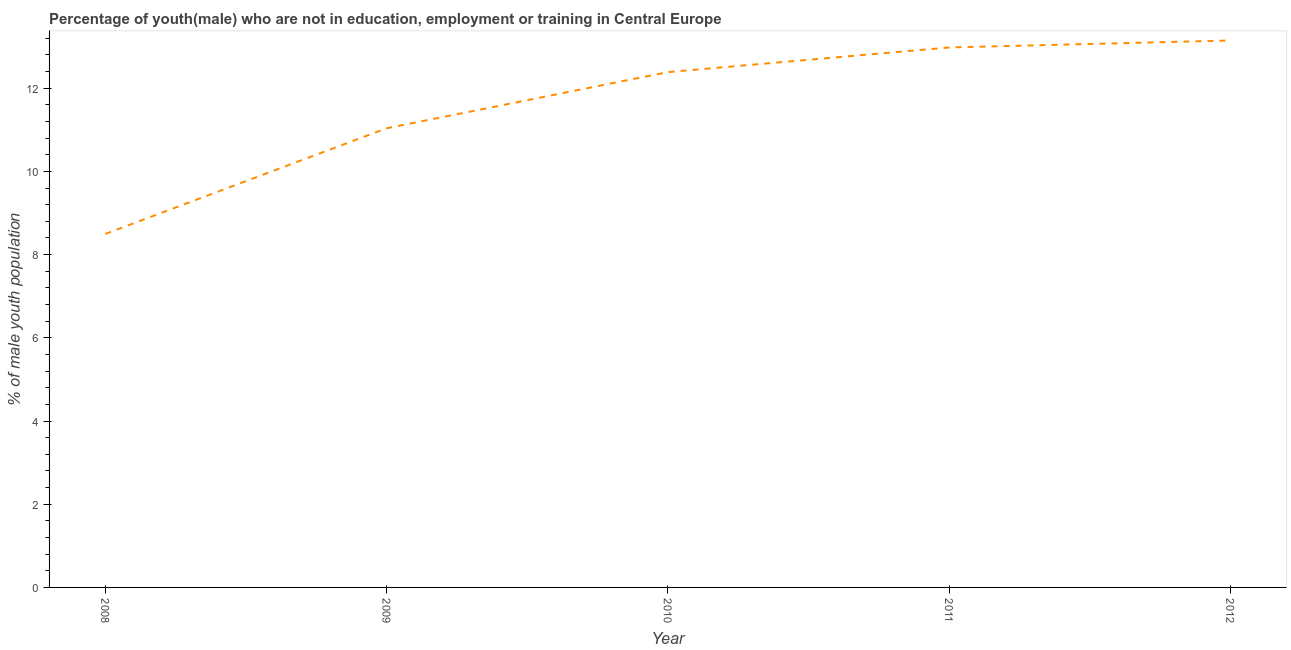What is the unemployed male youth population in 2008?
Your response must be concise. 8.5. Across all years, what is the maximum unemployed male youth population?
Give a very brief answer. 13.15. Across all years, what is the minimum unemployed male youth population?
Offer a very short reply. 8.5. In which year was the unemployed male youth population minimum?
Your answer should be very brief. 2008. What is the sum of the unemployed male youth population?
Provide a short and direct response. 58.05. What is the difference between the unemployed male youth population in 2010 and 2012?
Your answer should be very brief. -0.76. What is the average unemployed male youth population per year?
Your answer should be very brief. 11.61. What is the median unemployed male youth population?
Ensure brevity in your answer.  12.39. Do a majority of the years between 2010 and 2011 (inclusive) have unemployed male youth population greater than 4.4 %?
Give a very brief answer. Yes. What is the ratio of the unemployed male youth population in 2009 to that in 2012?
Make the answer very short. 0.84. Is the unemployed male youth population in 2010 less than that in 2011?
Offer a terse response. Yes. What is the difference between the highest and the second highest unemployed male youth population?
Make the answer very short. 0.17. What is the difference between the highest and the lowest unemployed male youth population?
Make the answer very short. 4.65. In how many years, is the unemployed male youth population greater than the average unemployed male youth population taken over all years?
Give a very brief answer. 3. What is the difference between two consecutive major ticks on the Y-axis?
Provide a short and direct response. 2. Does the graph contain any zero values?
Keep it short and to the point. No. What is the title of the graph?
Provide a succinct answer. Percentage of youth(male) who are not in education, employment or training in Central Europe. What is the label or title of the X-axis?
Give a very brief answer. Year. What is the label or title of the Y-axis?
Your answer should be compact. % of male youth population. What is the % of male youth population in 2008?
Offer a very short reply. 8.5. What is the % of male youth population in 2009?
Offer a terse response. 11.04. What is the % of male youth population in 2010?
Keep it short and to the point. 12.39. What is the % of male youth population in 2011?
Give a very brief answer. 12.98. What is the % of male youth population in 2012?
Provide a short and direct response. 13.15. What is the difference between the % of male youth population in 2008 and 2009?
Make the answer very short. -2.54. What is the difference between the % of male youth population in 2008 and 2010?
Provide a succinct answer. -3.89. What is the difference between the % of male youth population in 2008 and 2011?
Your answer should be very brief. -4.48. What is the difference between the % of male youth population in 2008 and 2012?
Ensure brevity in your answer.  -4.65. What is the difference between the % of male youth population in 2009 and 2010?
Give a very brief answer. -1.35. What is the difference between the % of male youth population in 2009 and 2011?
Keep it short and to the point. -1.94. What is the difference between the % of male youth population in 2009 and 2012?
Ensure brevity in your answer.  -2.11. What is the difference between the % of male youth population in 2010 and 2011?
Offer a terse response. -0.59. What is the difference between the % of male youth population in 2010 and 2012?
Make the answer very short. -0.76. What is the difference between the % of male youth population in 2011 and 2012?
Ensure brevity in your answer.  -0.17. What is the ratio of the % of male youth population in 2008 to that in 2009?
Keep it short and to the point. 0.77. What is the ratio of the % of male youth population in 2008 to that in 2010?
Ensure brevity in your answer.  0.69. What is the ratio of the % of male youth population in 2008 to that in 2011?
Your answer should be compact. 0.66. What is the ratio of the % of male youth population in 2008 to that in 2012?
Make the answer very short. 0.65. What is the ratio of the % of male youth population in 2009 to that in 2010?
Your answer should be compact. 0.89. What is the ratio of the % of male youth population in 2009 to that in 2012?
Offer a very short reply. 0.84. What is the ratio of the % of male youth population in 2010 to that in 2011?
Provide a succinct answer. 0.95. What is the ratio of the % of male youth population in 2010 to that in 2012?
Give a very brief answer. 0.94. What is the ratio of the % of male youth population in 2011 to that in 2012?
Offer a very short reply. 0.99. 